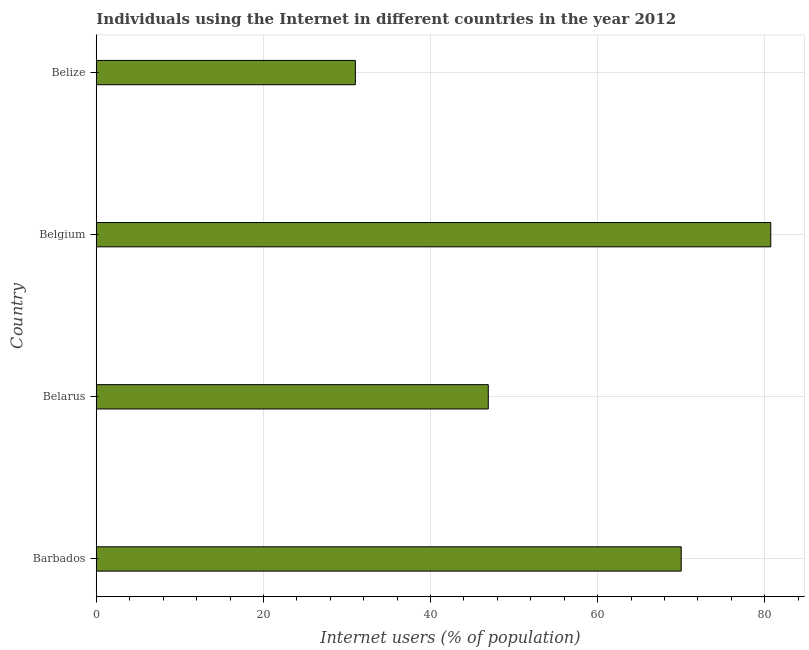Does the graph contain any zero values?
Offer a very short reply. No. Does the graph contain grids?
Give a very brief answer. Yes. What is the title of the graph?
Ensure brevity in your answer.  Individuals using the Internet in different countries in the year 2012. What is the label or title of the X-axis?
Your answer should be compact. Internet users (% of population). What is the label or title of the Y-axis?
Your answer should be compact. Country. What is the number of internet users in Belarus?
Your answer should be very brief. 46.91. Across all countries, what is the maximum number of internet users?
Your answer should be very brief. 80.72. Across all countries, what is the minimum number of internet users?
Your answer should be very brief. 31. In which country was the number of internet users maximum?
Offer a very short reply. Belgium. In which country was the number of internet users minimum?
Make the answer very short. Belize. What is the sum of the number of internet users?
Your answer should be compact. 228.63. What is the difference between the number of internet users in Barbados and Belgium?
Make the answer very short. -10.72. What is the average number of internet users per country?
Your answer should be compact. 57.16. What is the median number of internet users?
Your answer should be compact. 58.45. In how many countries, is the number of internet users greater than 80 %?
Your answer should be very brief. 1. What is the ratio of the number of internet users in Barbados to that in Belize?
Your answer should be very brief. 2.26. Is the number of internet users in Barbados less than that in Belize?
Give a very brief answer. No. What is the difference between the highest and the second highest number of internet users?
Give a very brief answer. 10.72. What is the difference between the highest and the lowest number of internet users?
Give a very brief answer. 49.72. How many bars are there?
Make the answer very short. 4. How many countries are there in the graph?
Your answer should be very brief. 4. What is the difference between two consecutive major ticks on the X-axis?
Offer a terse response. 20. Are the values on the major ticks of X-axis written in scientific E-notation?
Your response must be concise. No. What is the Internet users (% of population) in Barbados?
Keep it short and to the point. 70. What is the Internet users (% of population) of Belarus?
Your response must be concise. 46.91. What is the Internet users (% of population) in Belgium?
Your answer should be very brief. 80.72. What is the difference between the Internet users (% of population) in Barbados and Belarus?
Keep it short and to the point. 23.09. What is the difference between the Internet users (% of population) in Barbados and Belgium?
Offer a terse response. -10.72. What is the difference between the Internet users (% of population) in Belarus and Belgium?
Provide a short and direct response. -33.81. What is the difference between the Internet users (% of population) in Belarus and Belize?
Keep it short and to the point. 15.91. What is the difference between the Internet users (% of population) in Belgium and Belize?
Make the answer very short. 49.72. What is the ratio of the Internet users (% of population) in Barbados to that in Belarus?
Offer a very short reply. 1.49. What is the ratio of the Internet users (% of population) in Barbados to that in Belgium?
Ensure brevity in your answer.  0.87. What is the ratio of the Internet users (% of population) in Barbados to that in Belize?
Offer a terse response. 2.26. What is the ratio of the Internet users (% of population) in Belarus to that in Belgium?
Give a very brief answer. 0.58. What is the ratio of the Internet users (% of population) in Belarus to that in Belize?
Offer a terse response. 1.51. What is the ratio of the Internet users (% of population) in Belgium to that in Belize?
Your answer should be compact. 2.6. 